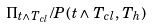<formula> <loc_0><loc_0><loc_500><loc_500>\Pi _ { t \wedge T _ { c l } } / P ( t \wedge T _ { c l } , T _ { h } )</formula> 